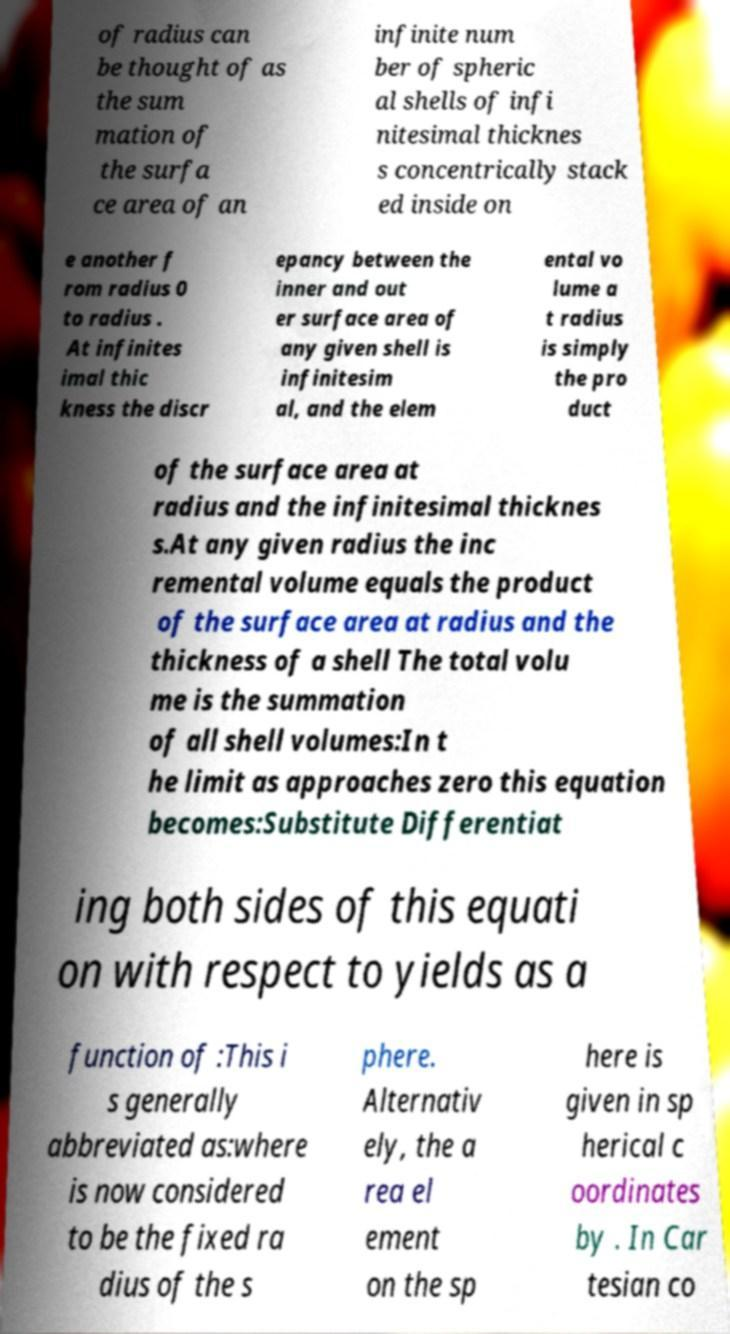I need the written content from this picture converted into text. Can you do that? of radius can be thought of as the sum mation of the surfa ce area of an infinite num ber of spheric al shells of infi nitesimal thicknes s concentrically stack ed inside on e another f rom radius 0 to radius . At infinites imal thic kness the discr epancy between the inner and out er surface area of any given shell is infinitesim al, and the elem ental vo lume a t radius is simply the pro duct of the surface area at radius and the infinitesimal thicknes s.At any given radius the inc remental volume equals the product of the surface area at radius and the thickness of a shell The total volu me is the summation of all shell volumes:In t he limit as approaches zero this equation becomes:Substitute Differentiat ing both sides of this equati on with respect to yields as a function of :This i s generally abbreviated as:where is now considered to be the fixed ra dius of the s phere. Alternativ ely, the a rea el ement on the sp here is given in sp herical c oordinates by . In Car tesian co 